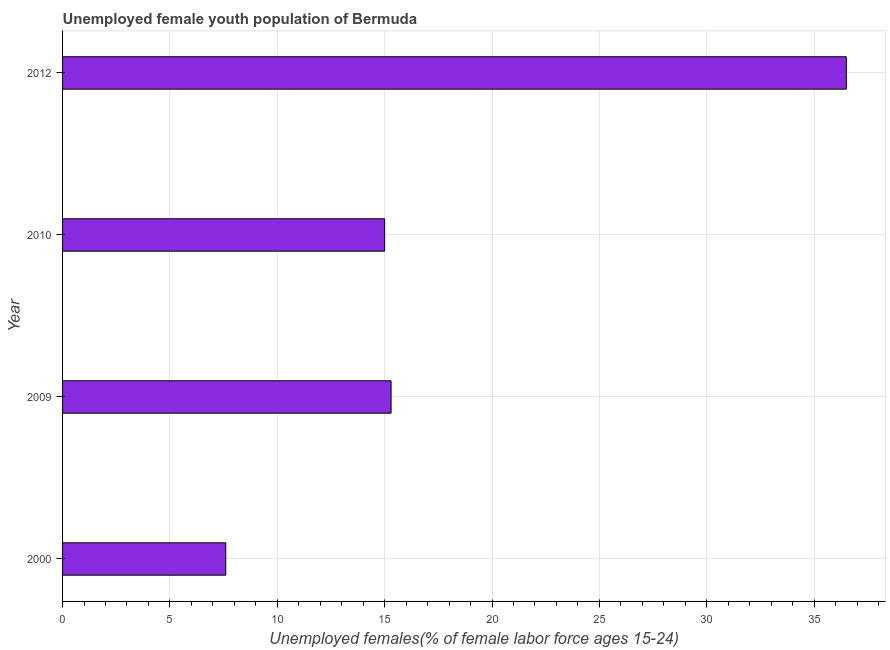Does the graph contain any zero values?
Provide a succinct answer. No. Does the graph contain grids?
Your answer should be compact. Yes. What is the title of the graph?
Ensure brevity in your answer.  Unemployed female youth population of Bermuda. What is the label or title of the X-axis?
Your answer should be very brief. Unemployed females(% of female labor force ages 15-24). What is the label or title of the Y-axis?
Provide a succinct answer. Year. What is the unemployed female youth in 2009?
Provide a short and direct response. 15.3. Across all years, what is the maximum unemployed female youth?
Make the answer very short. 36.5. Across all years, what is the minimum unemployed female youth?
Ensure brevity in your answer.  7.6. In which year was the unemployed female youth maximum?
Your response must be concise. 2012. In which year was the unemployed female youth minimum?
Make the answer very short. 2000. What is the sum of the unemployed female youth?
Offer a very short reply. 74.4. What is the median unemployed female youth?
Offer a terse response. 15.15. What is the ratio of the unemployed female youth in 2010 to that in 2012?
Provide a succinct answer. 0.41. Is the unemployed female youth in 2000 less than that in 2009?
Your response must be concise. Yes. Is the difference between the unemployed female youth in 2000 and 2010 greater than the difference between any two years?
Your answer should be very brief. No. What is the difference between the highest and the second highest unemployed female youth?
Give a very brief answer. 21.2. Is the sum of the unemployed female youth in 2000 and 2009 greater than the maximum unemployed female youth across all years?
Give a very brief answer. No. What is the difference between the highest and the lowest unemployed female youth?
Offer a terse response. 28.9. Are all the bars in the graph horizontal?
Your response must be concise. Yes. How many years are there in the graph?
Provide a succinct answer. 4. What is the difference between two consecutive major ticks on the X-axis?
Provide a short and direct response. 5. Are the values on the major ticks of X-axis written in scientific E-notation?
Give a very brief answer. No. What is the Unemployed females(% of female labor force ages 15-24) of 2000?
Provide a succinct answer. 7.6. What is the Unemployed females(% of female labor force ages 15-24) in 2009?
Provide a succinct answer. 15.3. What is the Unemployed females(% of female labor force ages 15-24) of 2010?
Your response must be concise. 15. What is the Unemployed females(% of female labor force ages 15-24) of 2012?
Your response must be concise. 36.5. What is the difference between the Unemployed females(% of female labor force ages 15-24) in 2000 and 2012?
Give a very brief answer. -28.9. What is the difference between the Unemployed females(% of female labor force ages 15-24) in 2009 and 2012?
Your answer should be very brief. -21.2. What is the difference between the Unemployed females(% of female labor force ages 15-24) in 2010 and 2012?
Your answer should be very brief. -21.5. What is the ratio of the Unemployed females(% of female labor force ages 15-24) in 2000 to that in 2009?
Provide a succinct answer. 0.5. What is the ratio of the Unemployed females(% of female labor force ages 15-24) in 2000 to that in 2010?
Offer a very short reply. 0.51. What is the ratio of the Unemployed females(% of female labor force ages 15-24) in 2000 to that in 2012?
Your answer should be very brief. 0.21. What is the ratio of the Unemployed females(% of female labor force ages 15-24) in 2009 to that in 2012?
Make the answer very short. 0.42. What is the ratio of the Unemployed females(% of female labor force ages 15-24) in 2010 to that in 2012?
Keep it short and to the point. 0.41. 